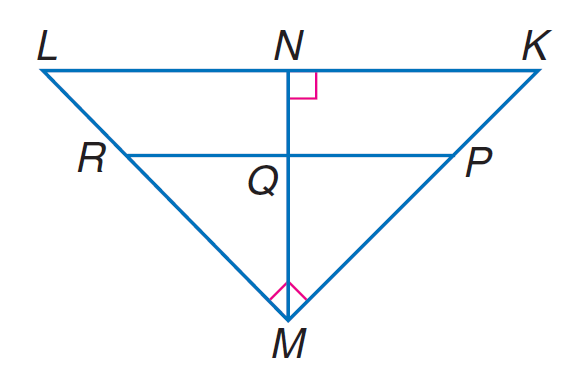Answer the mathemtical geometry problem and directly provide the correct option letter.
Question: If P R \parallel K L, K N = 9, L N = 16, P M = 2 K P, find M L.
Choices: A: 11 B: 18 C: 20 D: 25 C 